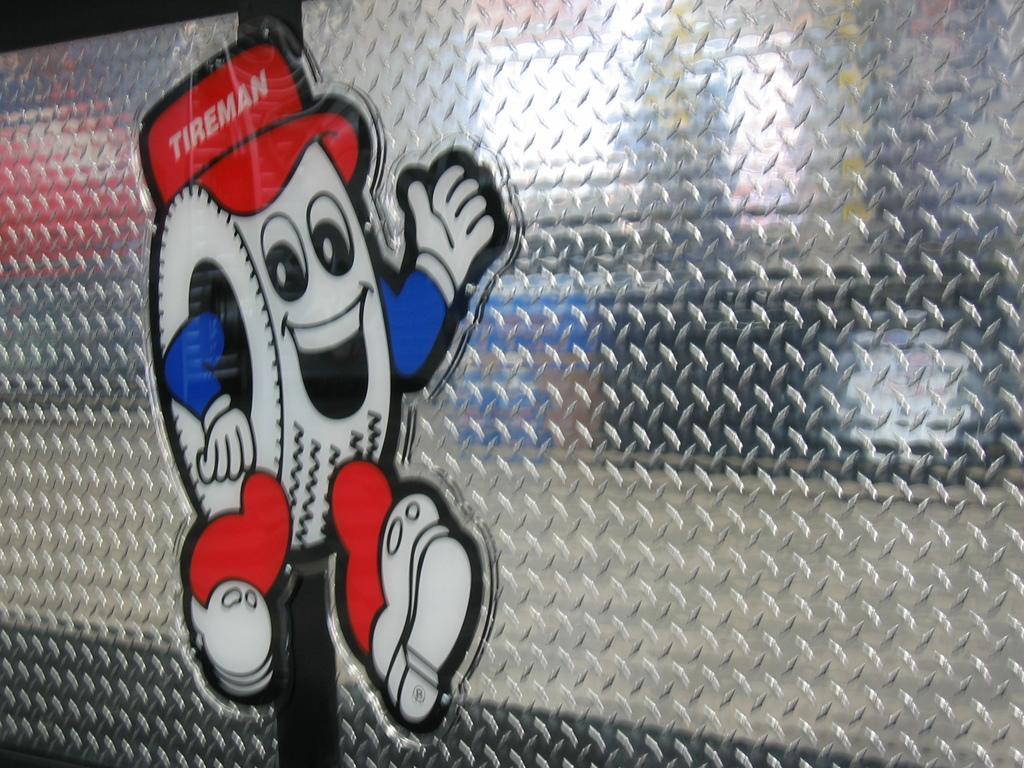In one or two sentences, can you explain what this image depicts? In this picture, we see the glass on which the sticker is placed. This sticker is in white, blue and red color. 